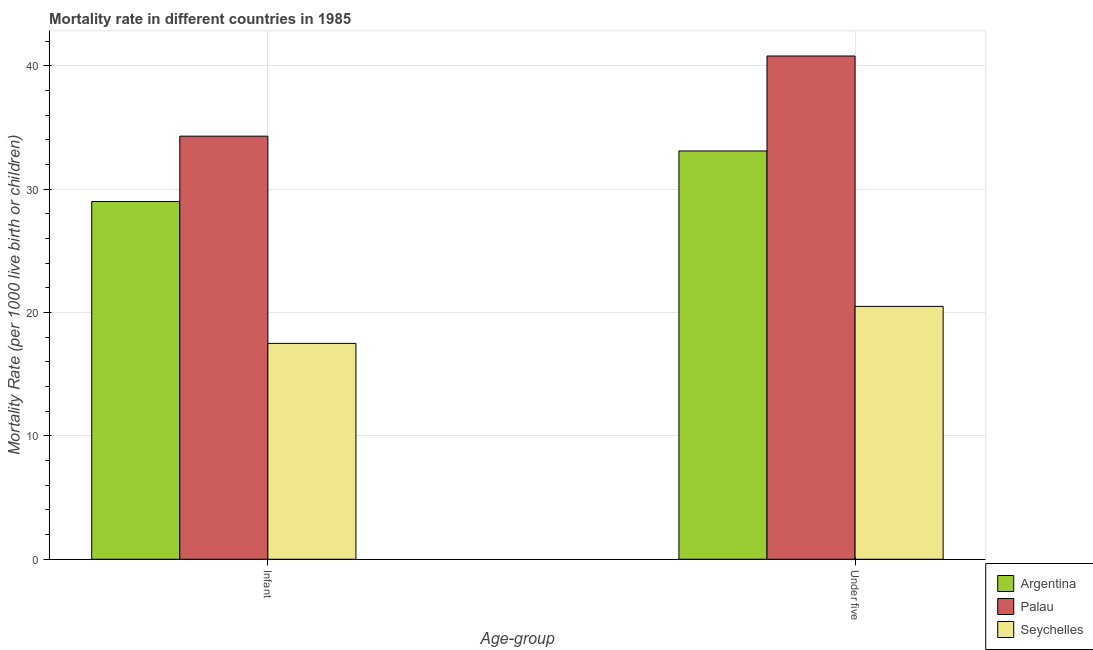How many groups of bars are there?
Ensure brevity in your answer.  2. Are the number of bars on each tick of the X-axis equal?
Keep it short and to the point. Yes. How many bars are there on the 1st tick from the left?
Your answer should be compact. 3. What is the label of the 1st group of bars from the left?
Keep it short and to the point. Infant. What is the under-5 mortality rate in Palau?
Provide a short and direct response. 40.8. Across all countries, what is the maximum under-5 mortality rate?
Your response must be concise. 40.8. Across all countries, what is the minimum infant mortality rate?
Ensure brevity in your answer.  17.5. In which country was the infant mortality rate maximum?
Your answer should be very brief. Palau. In which country was the under-5 mortality rate minimum?
Offer a terse response. Seychelles. What is the total under-5 mortality rate in the graph?
Your answer should be compact. 94.4. What is the difference between the infant mortality rate in Seychelles and that in Palau?
Give a very brief answer. -16.8. What is the difference between the infant mortality rate in Seychelles and the under-5 mortality rate in Palau?
Make the answer very short. -23.3. What is the average under-5 mortality rate per country?
Provide a succinct answer. 31.47. What is the difference between the infant mortality rate and under-5 mortality rate in Seychelles?
Offer a terse response. -3. What is the ratio of the under-5 mortality rate in Seychelles to that in Argentina?
Offer a very short reply. 0.62. What does the 2nd bar from the left in Under five represents?
Your response must be concise. Palau. What does the 2nd bar from the right in Under five represents?
Your answer should be very brief. Palau. How many countries are there in the graph?
Provide a succinct answer. 3. What is the difference between two consecutive major ticks on the Y-axis?
Keep it short and to the point. 10. Are the values on the major ticks of Y-axis written in scientific E-notation?
Offer a terse response. No. Does the graph contain grids?
Ensure brevity in your answer.  Yes. Where does the legend appear in the graph?
Ensure brevity in your answer.  Bottom right. What is the title of the graph?
Make the answer very short. Mortality rate in different countries in 1985. Does "Marshall Islands" appear as one of the legend labels in the graph?
Your response must be concise. No. What is the label or title of the X-axis?
Offer a terse response. Age-group. What is the label or title of the Y-axis?
Your answer should be compact. Mortality Rate (per 1000 live birth or children). What is the Mortality Rate (per 1000 live birth or children) in Palau in Infant?
Provide a succinct answer. 34.3. What is the Mortality Rate (per 1000 live birth or children) of Argentina in Under five?
Your answer should be compact. 33.1. What is the Mortality Rate (per 1000 live birth or children) of Palau in Under five?
Ensure brevity in your answer.  40.8. What is the Mortality Rate (per 1000 live birth or children) in Seychelles in Under five?
Give a very brief answer. 20.5. Across all Age-group, what is the maximum Mortality Rate (per 1000 live birth or children) in Argentina?
Provide a succinct answer. 33.1. Across all Age-group, what is the maximum Mortality Rate (per 1000 live birth or children) of Palau?
Keep it short and to the point. 40.8. Across all Age-group, what is the minimum Mortality Rate (per 1000 live birth or children) in Argentina?
Provide a short and direct response. 29. Across all Age-group, what is the minimum Mortality Rate (per 1000 live birth or children) of Palau?
Provide a short and direct response. 34.3. Across all Age-group, what is the minimum Mortality Rate (per 1000 live birth or children) in Seychelles?
Ensure brevity in your answer.  17.5. What is the total Mortality Rate (per 1000 live birth or children) in Argentina in the graph?
Provide a succinct answer. 62.1. What is the total Mortality Rate (per 1000 live birth or children) of Palau in the graph?
Ensure brevity in your answer.  75.1. What is the difference between the Mortality Rate (per 1000 live birth or children) in Argentina in Infant and that in Under five?
Offer a terse response. -4.1. What is the difference between the Mortality Rate (per 1000 live birth or children) of Palau in Infant and that in Under five?
Provide a short and direct response. -6.5. What is the difference between the Mortality Rate (per 1000 live birth or children) in Seychelles in Infant and that in Under five?
Provide a succinct answer. -3. What is the average Mortality Rate (per 1000 live birth or children) of Argentina per Age-group?
Keep it short and to the point. 31.05. What is the average Mortality Rate (per 1000 live birth or children) in Palau per Age-group?
Your answer should be compact. 37.55. What is the average Mortality Rate (per 1000 live birth or children) in Seychelles per Age-group?
Make the answer very short. 19. What is the difference between the Mortality Rate (per 1000 live birth or children) of Argentina and Mortality Rate (per 1000 live birth or children) of Palau in Infant?
Offer a terse response. -5.3. What is the difference between the Mortality Rate (per 1000 live birth or children) in Palau and Mortality Rate (per 1000 live birth or children) in Seychelles in Infant?
Ensure brevity in your answer.  16.8. What is the difference between the Mortality Rate (per 1000 live birth or children) of Argentina and Mortality Rate (per 1000 live birth or children) of Seychelles in Under five?
Provide a short and direct response. 12.6. What is the difference between the Mortality Rate (per 1000 live birth or children) in Palau and Mortality Rate (per 1000 live birth or children) in Seychelles in Under five?
Offer a very short reply. 20.3. What is the ratio of the Mortality Rate (per 1000 live birth or children) of Argentina in Infant to that in Under five?
Keep it short and to the point. 0.88. What is the ratio of the Mortality Rate (per 1000 live birth or children) of Palau in Infant to that in Under five?
Your answer should be very brief. 0.84. What is the ratio of the Mortality Rate (per 1000 live birth or children) in Seychelles in Infant to that in Under five?
Ensure brevity in your answer.  0.85. What is the difference between the highest and the lowest Mortality Rate (per 1000 live birth or children) in Argentina?
Your answer should be compact. 4.1. What is the difference between the highest and the lowest Mortality Rate (per 1000 live birth or children) in Palau?
Ensure brevity in your answer.  6.5. 